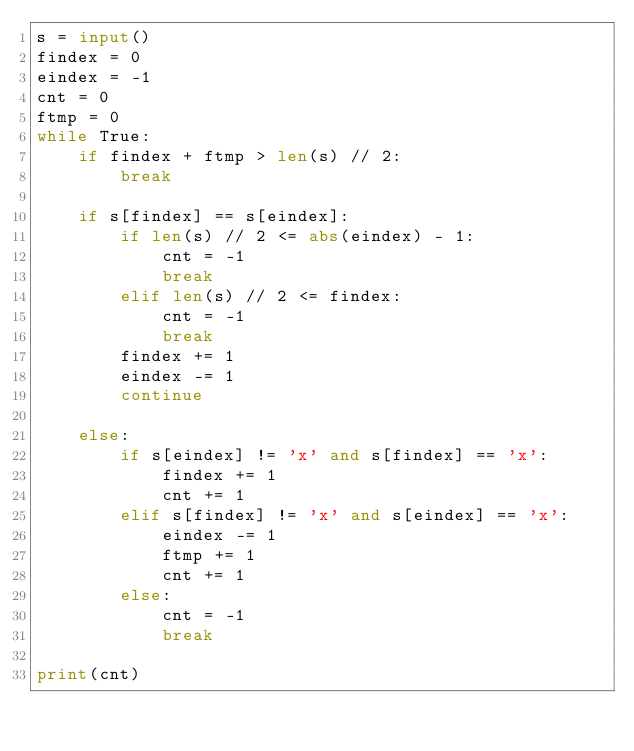<code> <loc_0><loc_0><loc_500><loc_500><_Python_>s = input()
findex = 0
eindex = -1
cnt = 0
ftmp = 0
while True:
    if findex + ftmp > len(s) // 2:
        break

    if s[findex] == s[eindex]:
        if len(s) // 2 <= abs(eindex) - 1:
            cnt = -1
            break
        elif len(s) // 2 <= findex:
            cnt = -1
            break
        findex += 1
        eindex -= 1
        continue

    else:
        if s[eindex] != 'x' and s[findex] == 'x':
            findex += 1
            cnt += 1
        elif s[findex] != 'x' and s[eindex] == 'x':
            eindex -= 1
            ftmp += 1
            cnt += 1
        else:
            cnt = -1
            break

print(cnt)</code> 